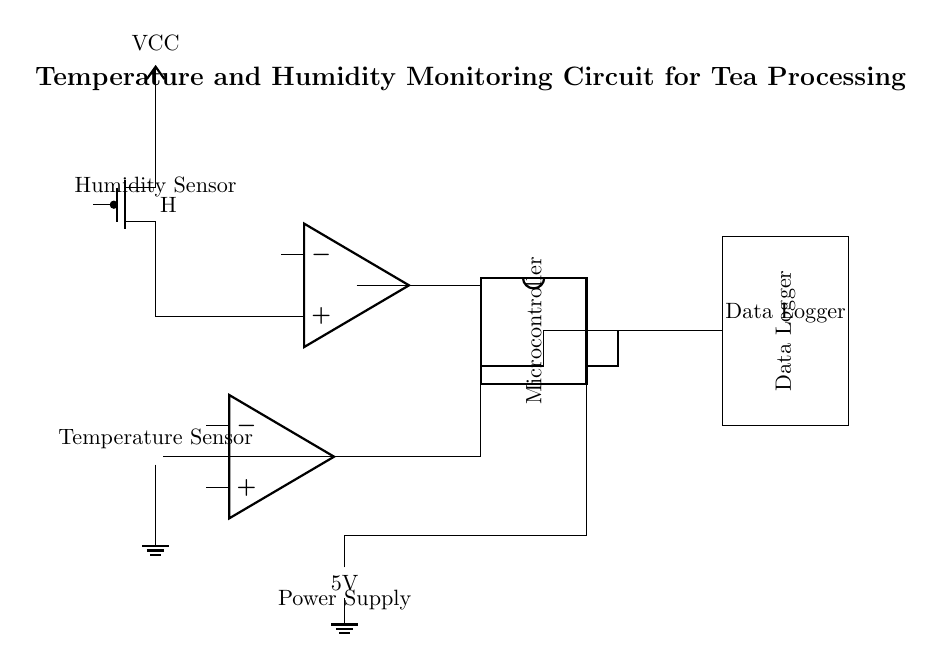What type of sensors are used in this circuit? The circuit contains a thermistor as a temperature sensor and a PMOS as a humidity sensor. The labels on the components indicate their types.
Answer: thermistor and PMOS What is the role of the microcontroller in this circuit? The microcontroller connects to the operational amplifiers and the data logger to process the signals from the sensors and manage data logging. It serves as the central processing unit of the circuit.
Answer: Data processing and logging What is the power supply voltage for the circuit? The circuit uses a 5V battery as its power supply, which is indicated next to the battery component in the circuit diagram.
Answer: 5V How many output signals does the microcontroller handle? The microcontroller is shown connecting to four pins, indicating that it handles at least four output signals corresponding to the connections from both sensors and the data logger.
Answer: Four Which components are connected to the data logger? The microcontroller pins three and four are connected to the data logger in the circuit, which allows it to send data from the processed signals.
Answer: Microcontroller pins three and four Explain the connection type between the temperature sensor and the microcontroller. The temperature sensor's output goes to an operational amplifier first, which then connects via a specific connection style (indicated by a line connecting the two) to the first pin on the microcontroller, allowing signal amplification before reaching the MCU.
Answer: Operational amplifier to microcontroller pin one 